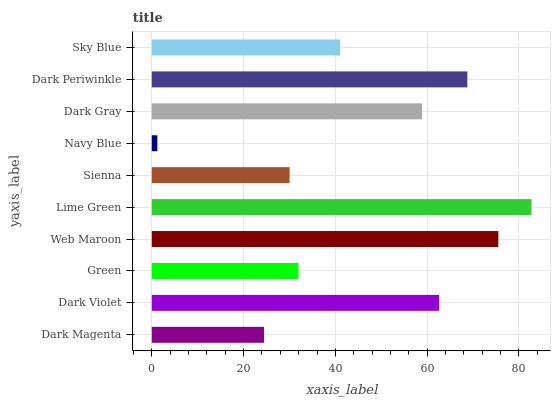Is Navy Blue the minimum?
Answer yes or no. Yes. Is Lime Green the maximum?
Answer yes or no. Yes. Is Dark Violet the minimum?
Answer yes or no. No. Is Dark Violet the maximum?
Answer yes or no. No. Is Dark Violet greater than Dark Magenta?
Answer yes or no. Yes. Is Dark Magenta less than Dark Violet?
Answer yes or no. Yes. Is Dark Magenta greater than Dark Violet?
Answer yes or no. No. Is Dark Violet less than Dark Magenta?
Answer yes or no. No. Is Dark Gray the high median?
Answer yes or no. Yes. Is Sky Blue the low median?
Answer yes or no. Yes. Is Navy Blue the high median?
Answer yes or no. No. Is Sienna the low median?
Answer yes or no. No. 